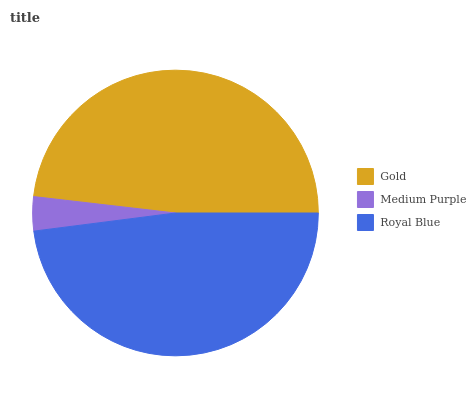Is Medium Purple the minimum?
Answer yes or no. Yes. Is Gold the maximum?
Answer yes or no. Yes. Is Royal Blue the minimum?
Answer yes or no. No. Is Royal Blue the maximum?
Answer yes or no. No. Is Royal Blue greater than Medium Purple?
Answer yes or no. Yes. Is Medium Purple less than Royal Blue?
Answer yes or no. Yes. Is Medium Purple greater than Royal Blue?
Answer yes or no. No. Is Royal Blue less than Medium Purple?
Answer yes or no. No. Is Royal Blue the high median?
Answer yes or no. Yes. Is Royal Blue the low median?
Answer yes or no. Yes. Is Gold the high median?
Answer yes or no. No. Is Medium Purple the low median?
Answer yes or no. No. 